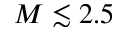<formula> <loc_0><loc_0><loc_500><loc_500>M \lesssim 2 . 5</formula> 